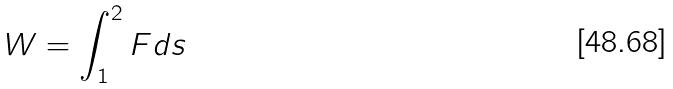Convert formula to latex. <formula><loc_0><loc_0><loc_500><loc_500>W = \int _ { 1 } ^ { 2 } F d s</formula> 